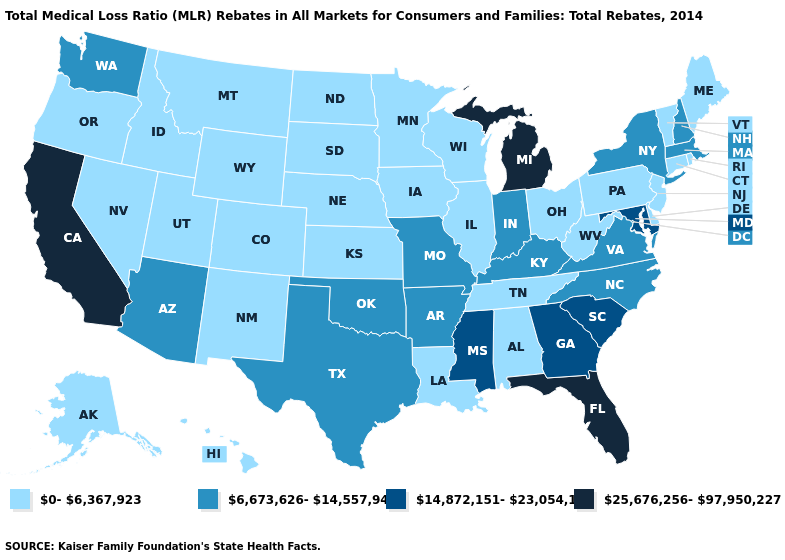Which states hav the highest value in the Northeast?
Be succinct. Massachusetts, New Hampshire, New York. Is the legend a continuous bar?
Be succinct. No. Name the states that have a value in the range 6,673,626-14,557,940?
Quick response, please. Arizona, Arkansas, Indiana, Kentucky, Massachusetts, Missouri, New Hampshire, New York, North Carolina, Oklahoma, Texas, Virginia, Washington. Does Montana have a lower value than Vermont?
Keep it brief. No. How many symbols are there in the legend?
Be succinct. 4. What is the value of North Dakota?
Be succinct. 0-6,367,923. Does Iowa have a higher value than Massachusetts?
Short answer required. No. What is the lowest value in the South?
Quick response, please. 0-6,367,923. Does Virginia have a lower value than California?
Quick response, please. Yes. Does California have the highest value in the USA?
Concise answer only. Yes. Is the legend a continuous bar?
Keep it brief. No. What is the value of Mississippi?
Answer briefly. 14,872,151-23,054,136. What is the value of Kentucky?
Be succinct. 6,673,626-14,557,940. Does Arizona have a higher value than West Virginia?
Write a very short answer. Yes. Among the states that border Kansas , which have the highest value?
Write a very short answer. Missouri, Oklahoma. 